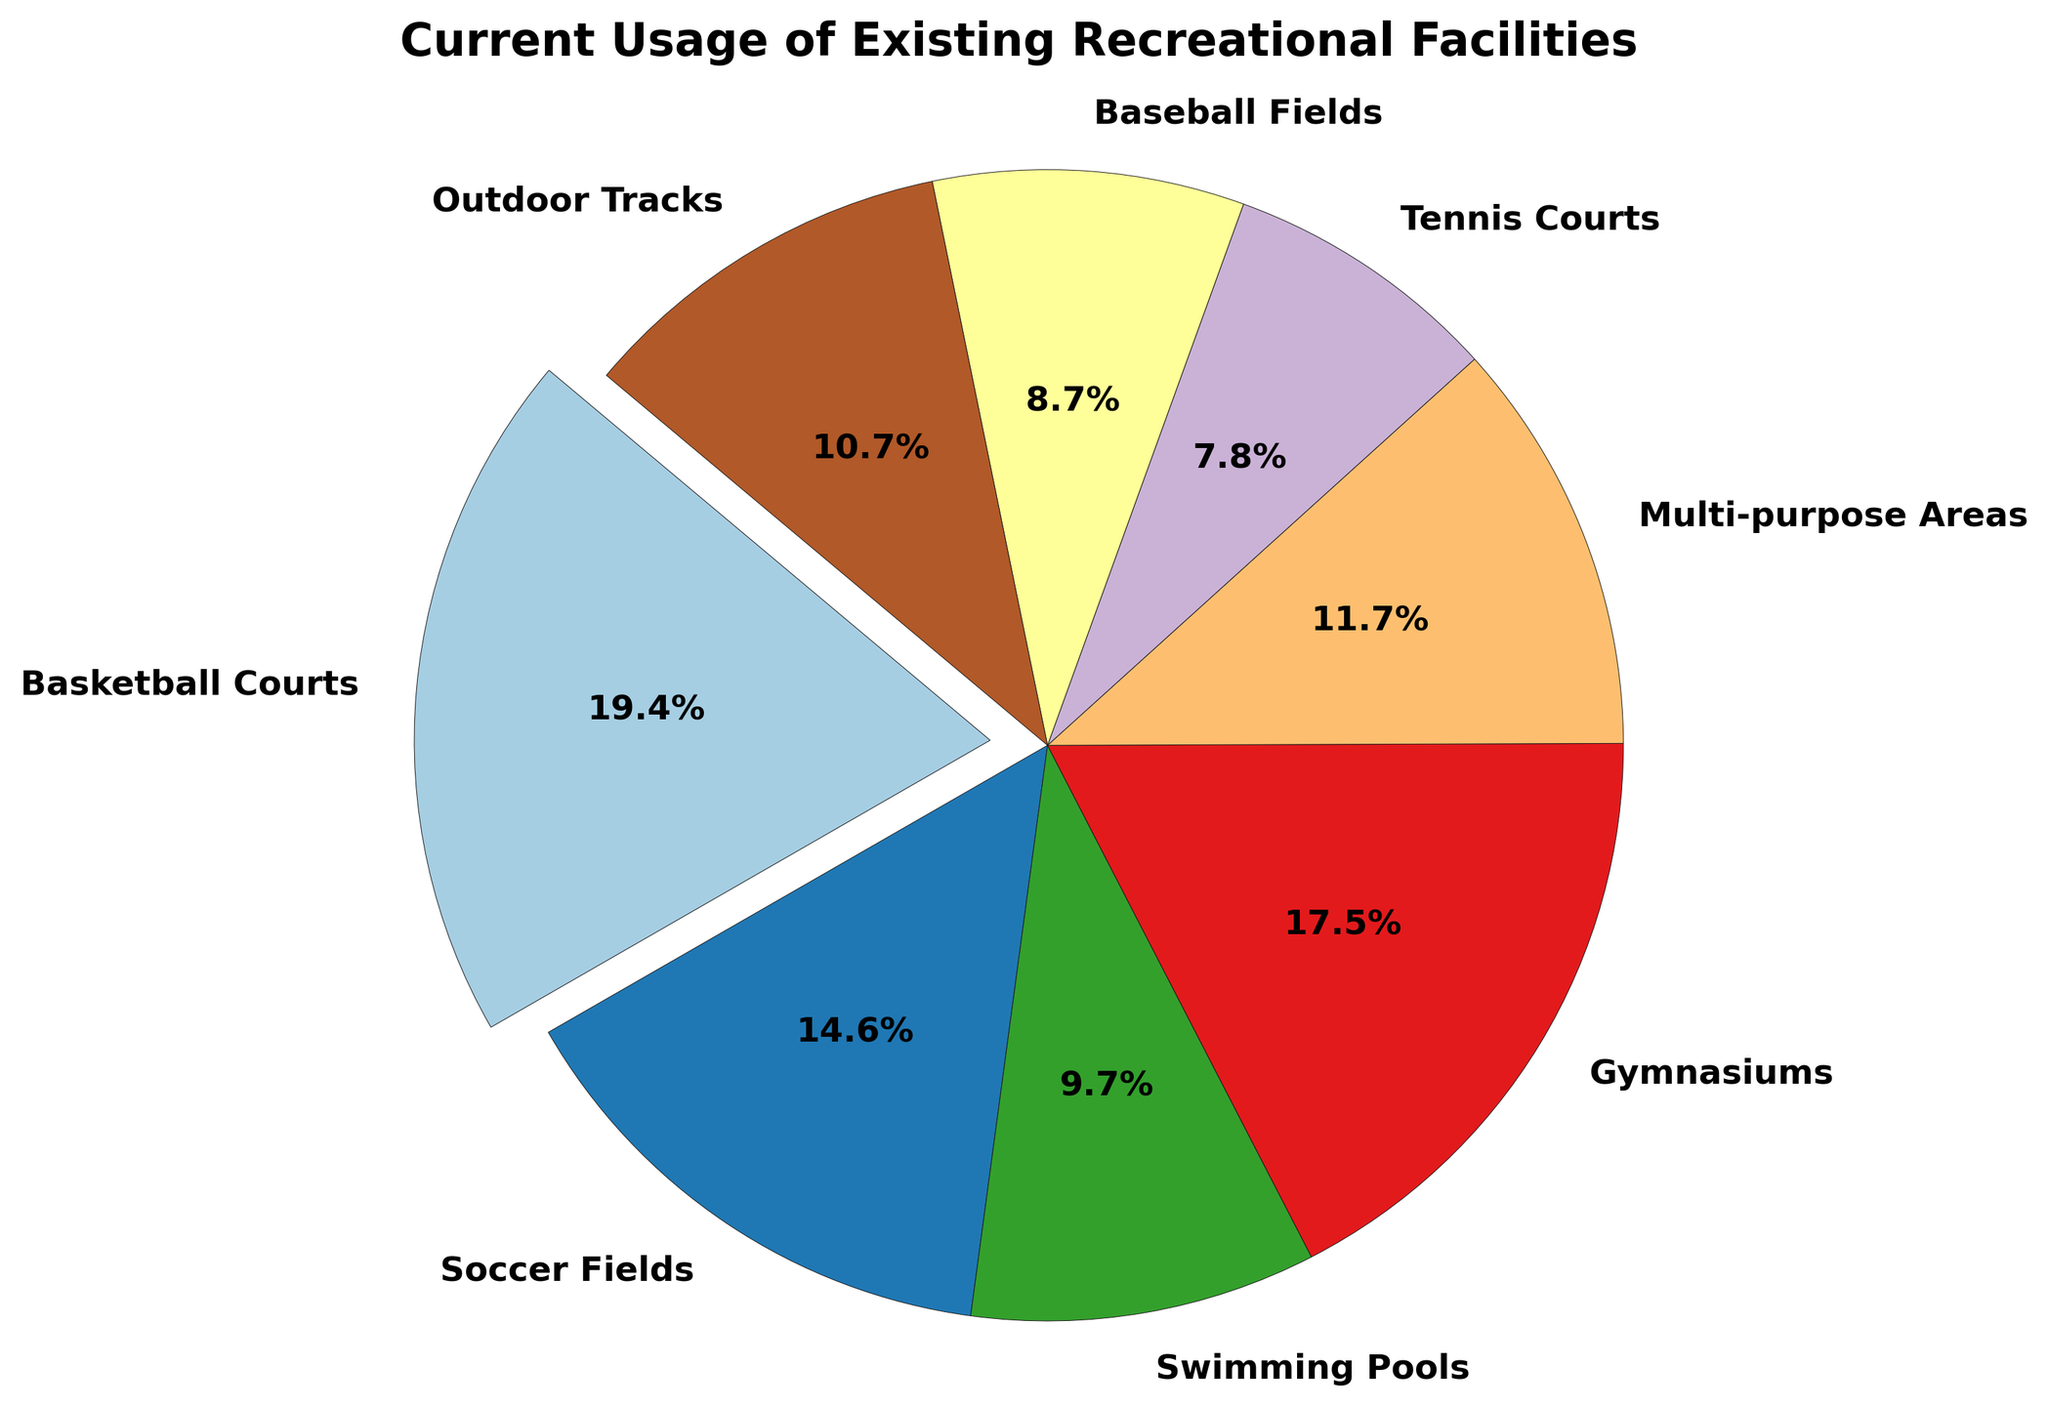What facility has the highest usage hours per week? Looking at the pie chart, the largest segment will represent the facility with the highest usage hours. The pie slice that is 'exploded' highlights the facility with the maximum usage. Here, the largest segment belongs to Basketball Courts.
Answer: Basketball Courts What percentage of total usage hours is attributed to Gymnasiums? The pie chart provides percentage labels for each segment. Locate the segment labeled "Gymnasiums" and read the corresponding percentage value.
Answer: 24.0% Compare the usage hours of Soccer Fields and Swimming Pools. Which one is used more and by how much? Find and compare the percentage slices for Soccer Fields and Swimming Pools. The Soccer Fields segment represents 18.0% while the Swimming Pools segment represents 12.0%. The difference in usage hours is derived from 18.0% - 12.0% = 6.0%.
Answer: Soccer Fields are used 6.0% more Which facilities combined make up over 50% of the total usage hours? Identify the segments that contribute to the cumulative percentage exceeding 50%. Starting with the largest, combining Basketball Courts (27.0%) and Gymnasiums (24.0%) yields 51.0%.
Answer: Basketball Courts and Gymnasiums What is the total usage percentage of facilities other than the top two most used facilities? First, identify the top two used facilities: Basketball Courts (27.0%) and Gymnasiums (24.0%). Their combined percentage is 51.0%. Subtract this from 100% to calculate the percentage of the remaining facilities: 100% - 51.0% = 49.0%.
Answer: 49.0% How do the usage hours of Tennis Courts compare to Baseball Fields, and what’s their combined percentage of the total usage? Locate the segments for Tennis Courts (10.8%) and Baseball Fields (12.2%). Tennis Courts have a smaller percentage compared to Baseball Fields. Combined, they account for 10.8% + 12.2% = 23.0%.
Answer: Tennis Courts have a 1.4% lower usage and their combined total is 23.0% Which facility is represented with the smallest segment in the pie chart, and what percentage does it represent? The smallest pie segment corresponds to the facility with the least usage. Here, Tennis Courts have the smallest segment representing 10.0%.
Answer: Tennis Courts with 10.0% What percentage more are the usage hours of Basketball Courts compared to Multi-purpose Areas? Identify the percentage labels: Basketball Courts (27.0%) and Multi-purpose Areas (16.2%). The difference is calculated as 27.0% - 16.2% = 10.8%.
Answer: 10.8% more 